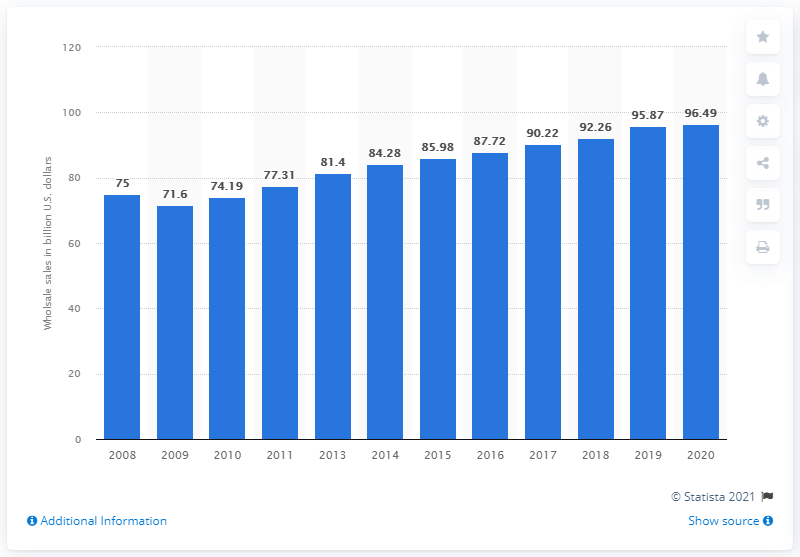Give some essential details in this illustration. In 2020, the value of wholesale sales in the U.S. was 96.49. 